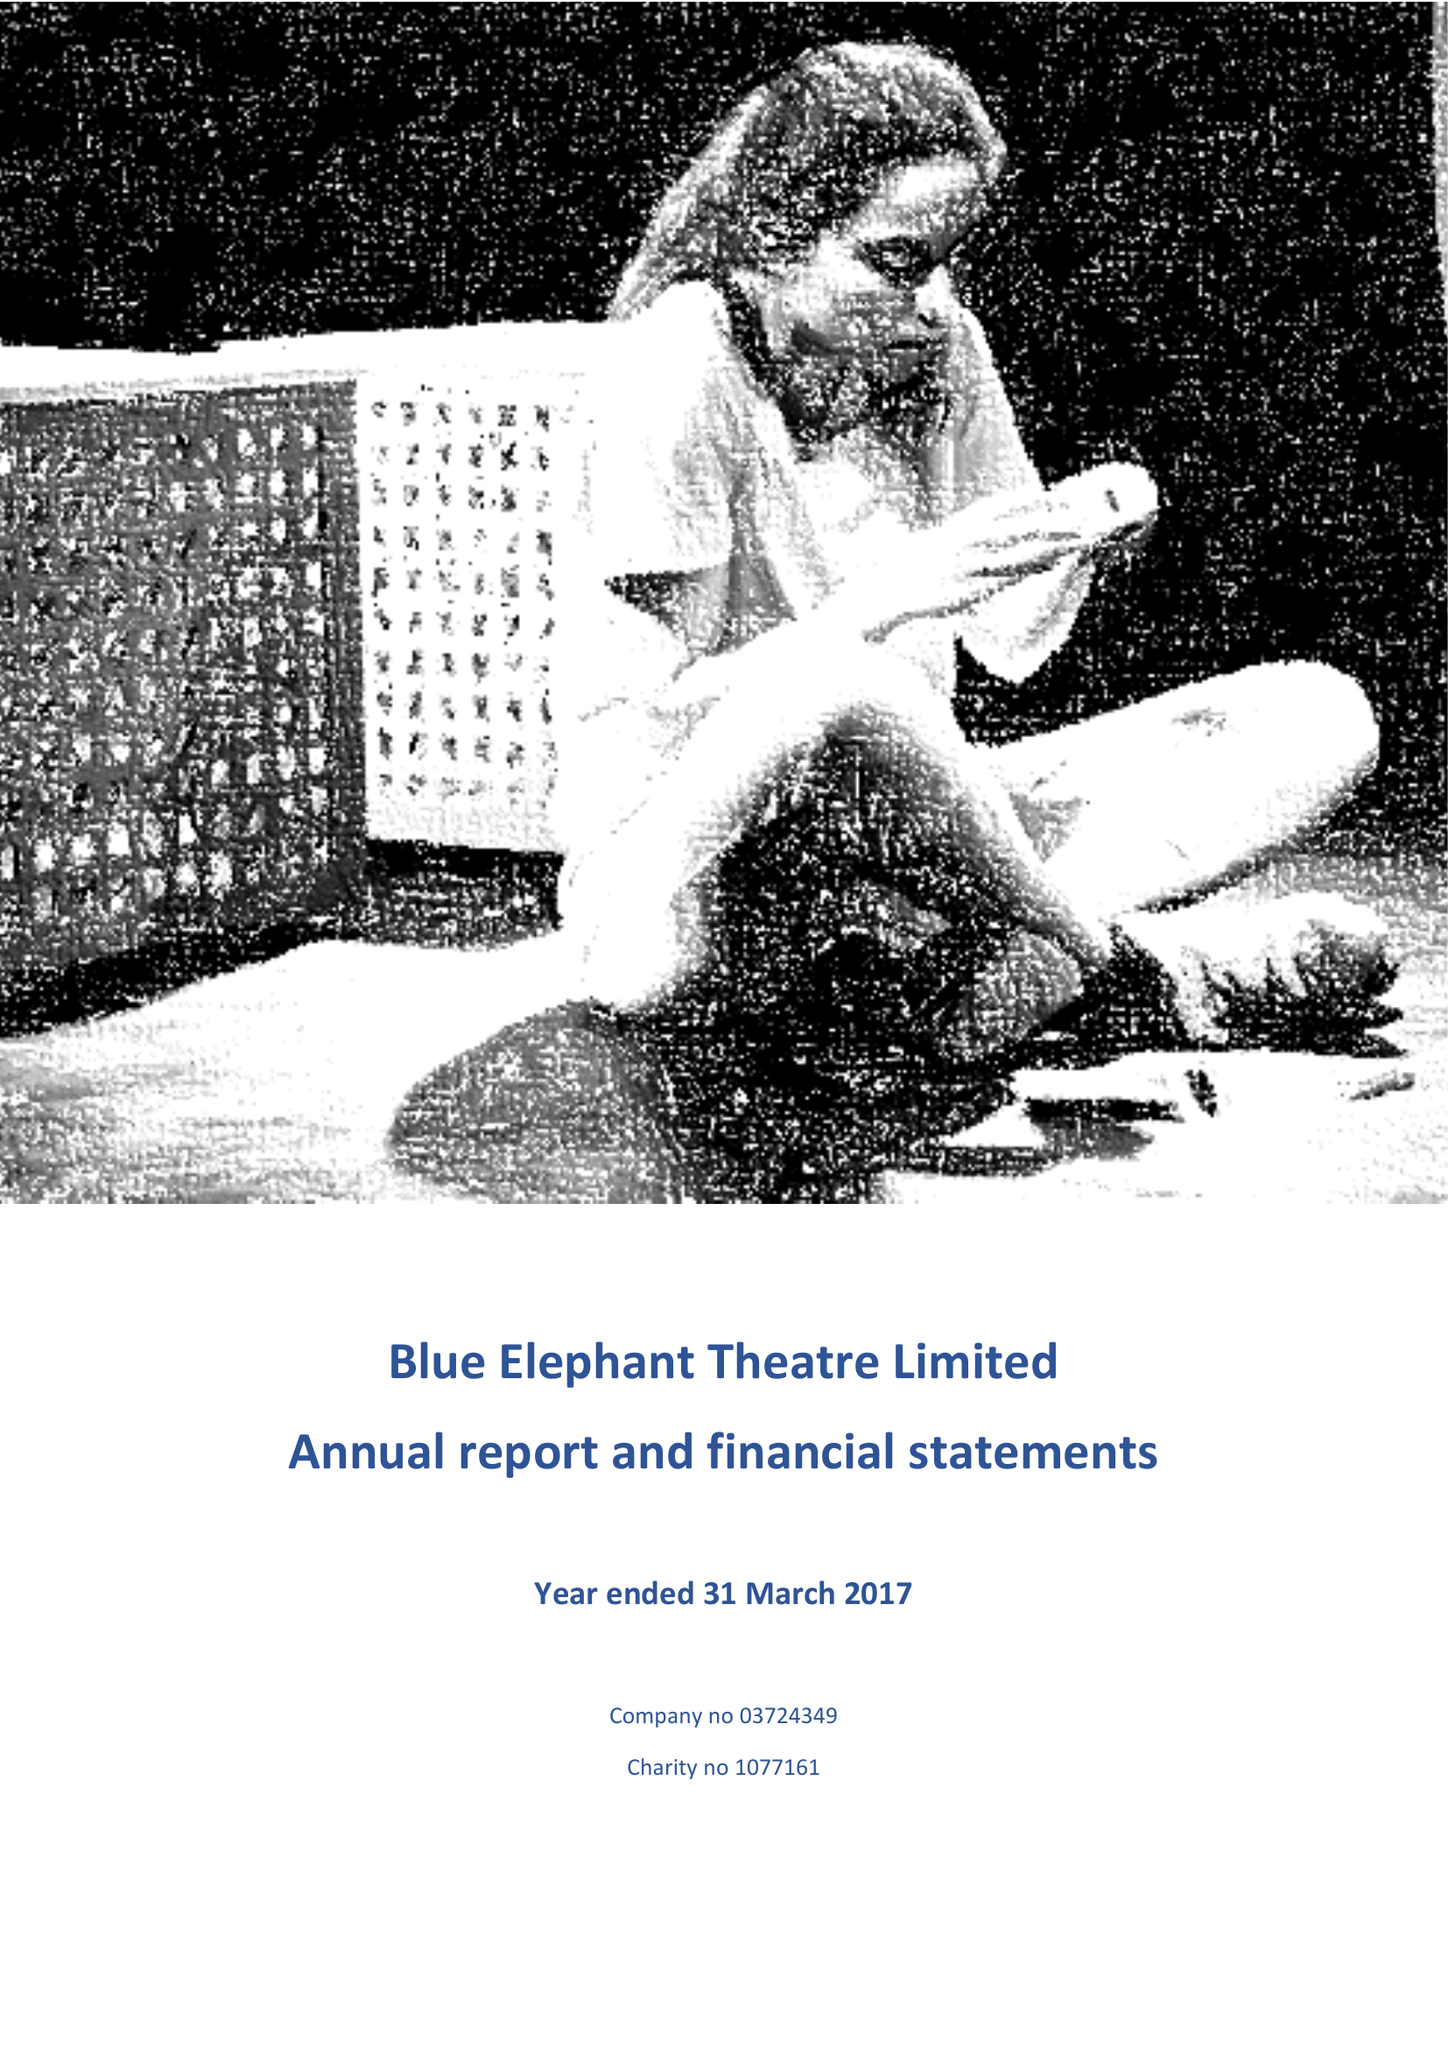What is the value for the spending_annually_in_british_pounds?
Answer the question using a single word or phrase. 149759.00 